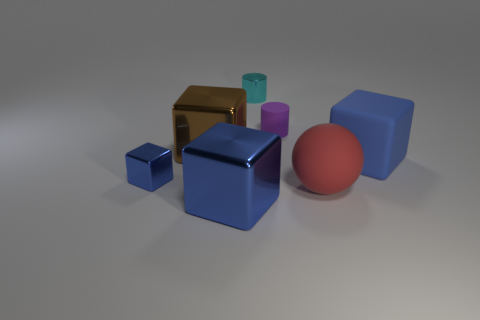What is the material of the tiny thing that is the same color as the rubber cube?
Provide a short and direct response. Metal. Is there a large matte sphere left of the ball on the right side of the small blue cube that is left of the red rubber object?
Keep it short and to the point. No. Does the blue cube to the right of the matte cylinder have the same material as the tiny cylinder that is behind the small purple cylinder?
Your answer should be compact. No. How many objects are either small purple matte cylinders or objects to the left of the tiny cyan object?
Provide a short and direct response. 4. What number of tiny cyan rubber objects are the same shape as the purple matte thing?
Your response must be concise. 0. There is a cube that is the same size as the cyan metal thing; what is it made of?
Your answer should be compact. Metal. There is a blue metallic object in front of the tiny thing in front of the purple thing behind the brown cube; how big is it?
Provide a succinct answer. Large. There is a big metallic cube behind the rubber ball; is its color the same as the block that is on the right side of the shiny cylinder?
Give a very brief answer. No. How many cyan things are either spheres or small metal things?
Your answer should be compact. 1. How many blocks are the same size as the matte sphere?
Provide a short and direct response. 3. 